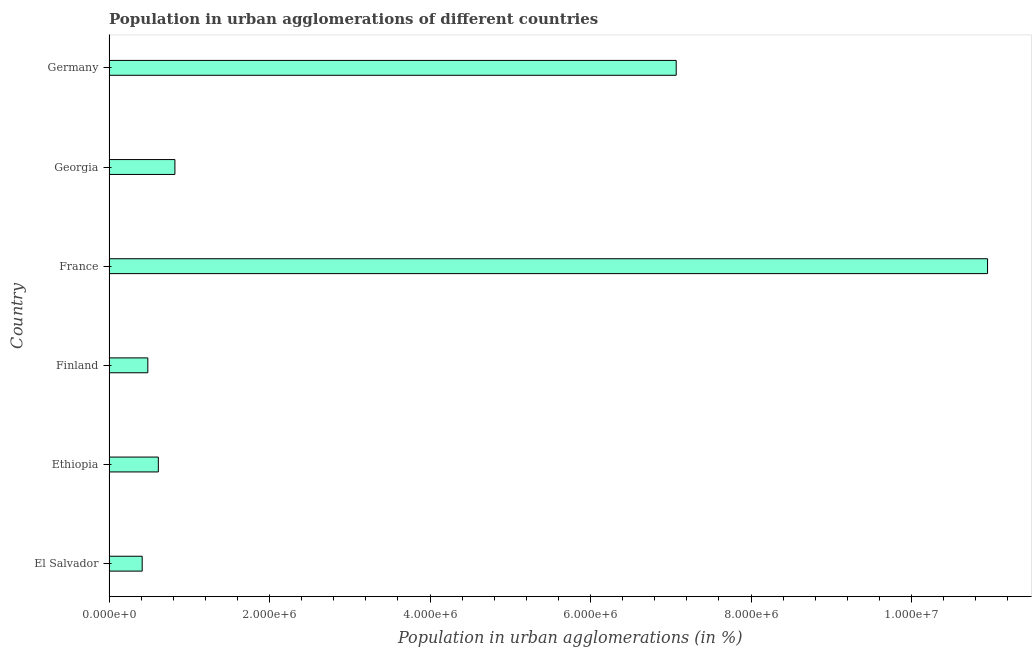Does the graph contain any zero values?
Keep it short and to the point. No. What is the title of the graph?
Make the answer very short. Population in urban agglomerations of different countries. What is the label or title of the X-axis?
Keep it short and to the point. Population in urban agglomerations (in %). What is the population in urban agglomerations in El Salvador?
Your answer should be compact. 4.13e+05. Across all countries, what is the maximum population in urban agglomerations?
Ensure brevity in your answer.  1.09e+07. Across all countries, what is the minimum population in urban agglomerations?
Provide a succinct answer. 4.13e+05. In which country was the population in urban agglomerations maximum?
Give a very brief answer. France. In which country was the population in urban agglomerations minimum?
Give a very brief answer. El Salvador. What is the sum of the population in urban agglomerations?
Make the answer very short. 2.03e+07. What is the difference between the population in urban agglomerations in Ethiopia and Georgia?
Ensure brevity in your answer.  -2.07e+05. What is the average population in urban agglomerations per country?
Provide a succinct answer. 3.39e+06. What is the median population in urban agglomerations?
Ensure brevity in your answer.  7.18e+05. In how many countries, is the population in urban agglomerations greater than 8800000 %?
Your answer should be compact. 1. What is the ratio of the population in urban agglomerations in El Salvador to that in France?
Your answer should be compact. 0.04. Is the population in urban agglomerations in El Salvador less than that in France?
Make the answer very short. Yes. What is the difference between the highest and the second highest population in urban agglomerations?
Keep it short and to the point. 3.88e+06. What is the difference between the highest and the lowest population in urban agglomerations?
Provide a succinct answer. 1.05e+07. In how many countries, is the population in urban agglomerations greater than the average population in urban agglomerations taken over all countries?
Ensure brevity in your answer.  2. How many bars are there?
Ensure brevity in your answer.  6. Are all the bars in the graph horizontal?
Make the answer very short. Yes. How many countries are there in the graph?
Offer a very short reply. 6. What is the difference between two consecutive major ticks on the X-axis?
Offer a very short reply. 2.00e+06. What is the Population in urban agglomerations (in %) of El Salvador?
Provide a short and direct response. 4.13e+05. What is the Population in urban agglomerations (in %) in Ethiopia?
Ensure brevity in your answer.  6.14e+05. What is the Population in urban agglomerations (in %) in Finland?
Give a very brief answer. 4.84e+05. What is the Population in urban agglomerations (in %) in France?
Your answer should be very brief. 1.09e+07. What is the Population in urban agglomerations (in %) in Georgia?
Provide a short and direct response. 8.21e+05. What is the Population in urban agglomerations (in %) in Germany?
Provide a short and direct response. 7.07e+06. What is the difference between the Population in urban agglomerations (in %) in El Salvador and Ethiopia?
Your answer should be compact. -2.01e+05. What is the difference between the Population in urban agglomerations (in %) in El Salvador and Finland?
Your response must be concise. -7.02e+04. What is the difference between the Population in urban agglomerations (in %) in El Salvador and France?
Keep it short and to the point. -1.05e+07. What is the difference between the Population in urban agglomerations (in %) in El Salvador and Georgia?
Keep it short and to the point. -4.08e+05. What is the difference between the Population in urban agglomerations (in %) in El Salvador and Germany?
Ensure brevity in your answer.  -6.65e+06. What is the difference between the Population in urban agglomerations (in %) in Ethiopia and Finland?
Your response must be concise. 1.31e+05. What is the difference between the Population in urban agglomerations (in %) in Ethiopia and France?
Your answer should be very brief. -1.03e+07. What is the difference between the Population in urban agglomerations (in %) in Ethiopia and Georgia?
Provide a short and direct response. -2.07e+05. What is the difference between the Population in urban agglomerations (in %) in Ethiopia and Germany?
Keep it short and to the point. -6.45e+06. What is the difference between the Population in urban agglomerations (in %) in Finland and France?
Offer a terse response. -1.05e+07. What is the difference between the Population in urban agglomerations (in %) in Finland and Georgia?
Your answer should be compact. -3.38e+05. What is the difference between the Population in urban agglomerations (in %) in Finland and Germany?
Provide a short and direct response. -6.58e+06. What is the difference between the Population in urban agglomerations (in %) in France and Georgia?
Provide a succinct answer. 1.01e+07. What is the difference between the Population in urban agglomerations (in %) in France and Germany?
Provide a short and direct response. 3.88e+06. What is the difference between the Population in urban agglomerations (in %) in Georgia and Germany?
Give a very brief answer. -6.25e+06. What is the ratio of the Population in urban agglomerations (in %) in El Salvador to that in Ethiopia?
Your answer should be very brief. 0.67. What is the ratio of the Population in urban agglomerations (in %) in El Salvador to that in Finland?
Give a very brief answer. 0.85. What is the ratio of the Population in urban agglomerations (in %) in El Salvador to that in France?
Provide a short and direct response. 0.04. What is the ratio of the Population in urban agglomerations (in %) in El Salvador to that in Georgia?
Keep it short and to the point. 0.5. What is the ratio of the Population in urban agglomerations (in %) in El Salvador to that in Germany?
Your answer should be very brief. 0.06. What is the ratio of the Population in urban agglomerations (in %) in Ethiopia to that in Finland?
Provide a succinct answer. 1.27. What is the ratio of the Population in urban agglomerations (in %) in Ethiopia to that in France?
Keep it short and to the point. 0.06. What is the ratio of the Population in urban agglomerations (in %) in Ethiopia to that in Georgia?
Give a very brief answer. 0.75. What is the ratio of the Population in urban agglomerations (in %) in Ethiopia to that in Germany?
Your response must be concise. 0.09. What is the ratio of the Population in urban agglomerations (in %) in Finland to that in France?
Keep it short and to the point. 0.04. What is the ratio of the Population in urban agglomerations (in %) in Finland to that in Georgia?
Keep it short and to the point. 0.59. What is the ratio of the Population in urban agglomerations (in %) in Finland to that in Germany?
Your answer should be very brief. 0.07. What is the ratio of the Population in urban agglomerations (in %) in France to that in Georgia?
Offer a terse response. 13.33. What is the ratio of the Population in urban agglomerations (in %) in France to that in Germany?
Keep it short and to the point. 1.55. What is the ratio of the Population in urban agglomerations (in %) in Georgia to that in Germany?
Offer a very short reply. 0.12. 